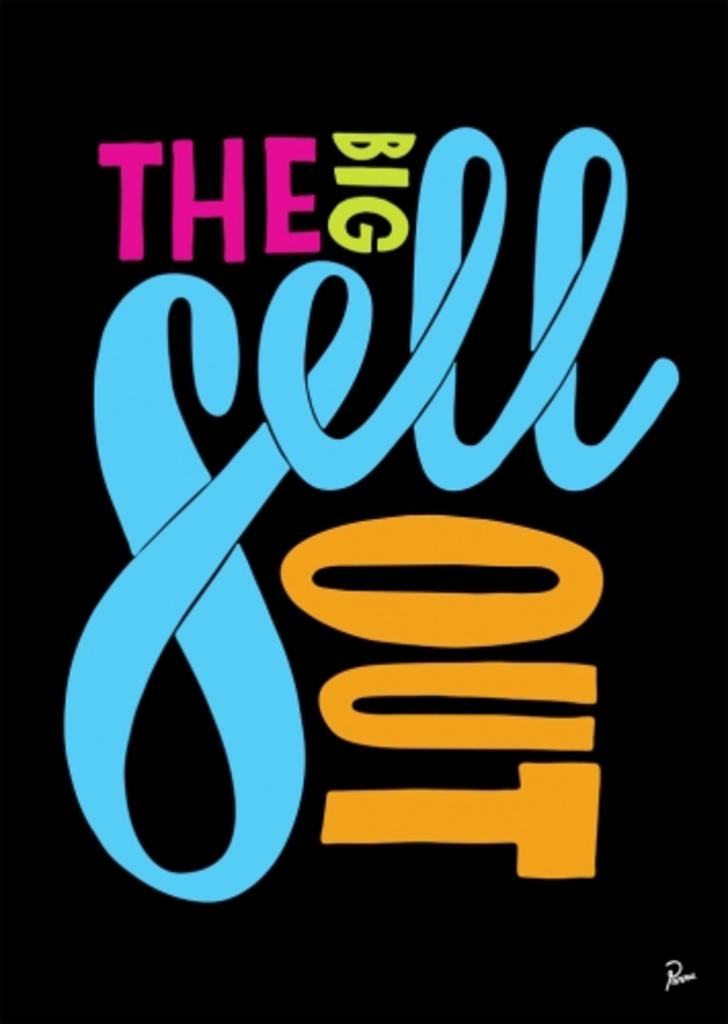<image>
Present a compact description of the photo's key features. A simple black poster with The Big Sell Out in bright colors. 